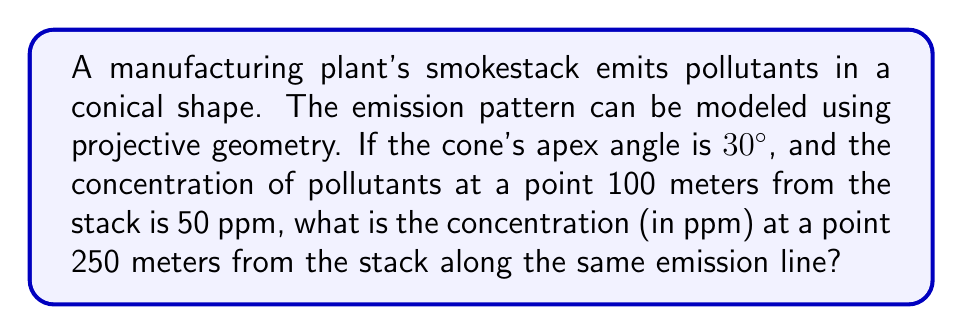Show me your answer to this math problem. To solve this problem, we'll use projective geometry concepts and the inverse square law for pollutant dispersion:

1) In projective geometry, we can model the emission cone as a projective conic section.

2) The inverse square law states that the concentration of pollutants is inversely proportional to the square of the distance from the source.

3) Let $C_1$ be the concentration at distance $d_1$, and $C_2$ be the concentration at distance $d_2$. The inverse square law gives us:

   $$\frac{C_1}{C_2} = \frac{d_2^2}{d_1^2}$$

4) We're given:
   $C_1 = 50$ ppm
   $d_1 = 100$ meters
   $d_2 = 250$ meters

5) Substituting these values:

   $$\frac{50}{C_2} = \frac{250^2}{100^2}$$

6) Simplify:
   $$\frac{50}{C_2} = \frac{62500}{10000} = 6.25$$

7) Solve for $C_2$:
   $$C_2 = \frac{50}{6.25} = 8$$

Therefore, the concentration at 250 meters is 8 ppm.

Note: The apex angle of 30° doesn't affect this calculation but would be relevant if we were considering the spread of the pollutants in three dimensions.
Answer: 8 ppm 